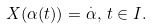Convert formula to latex. <formula><loc_0><loc_0><loc_500><loc_500>X ( \alpha ( t ) ) = \overset { . } { \alpha } , \, t \in I .</formula> 